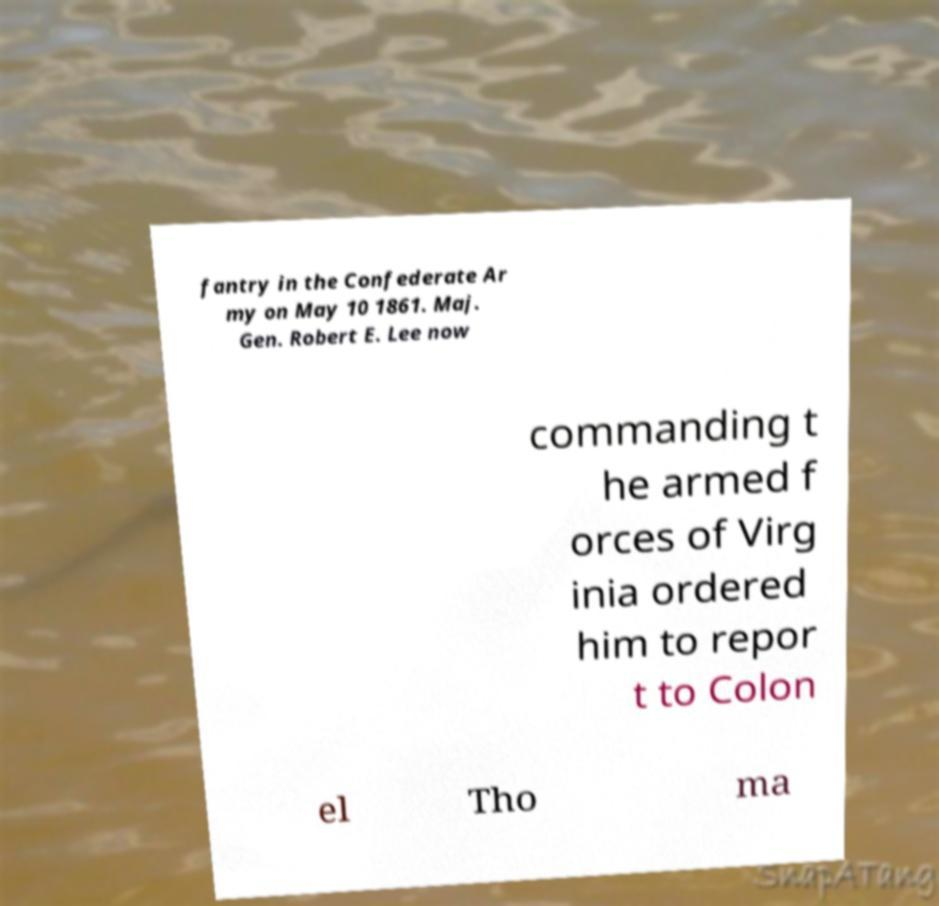Please identify and transcribe the text found in this image. fantry in the Confederate Ar my on May 10 1861. Maj. Gen. Robert E. Lee now commanding t he armed f orces of Virg inia ordered him to repor t to Colon el Tho ma 